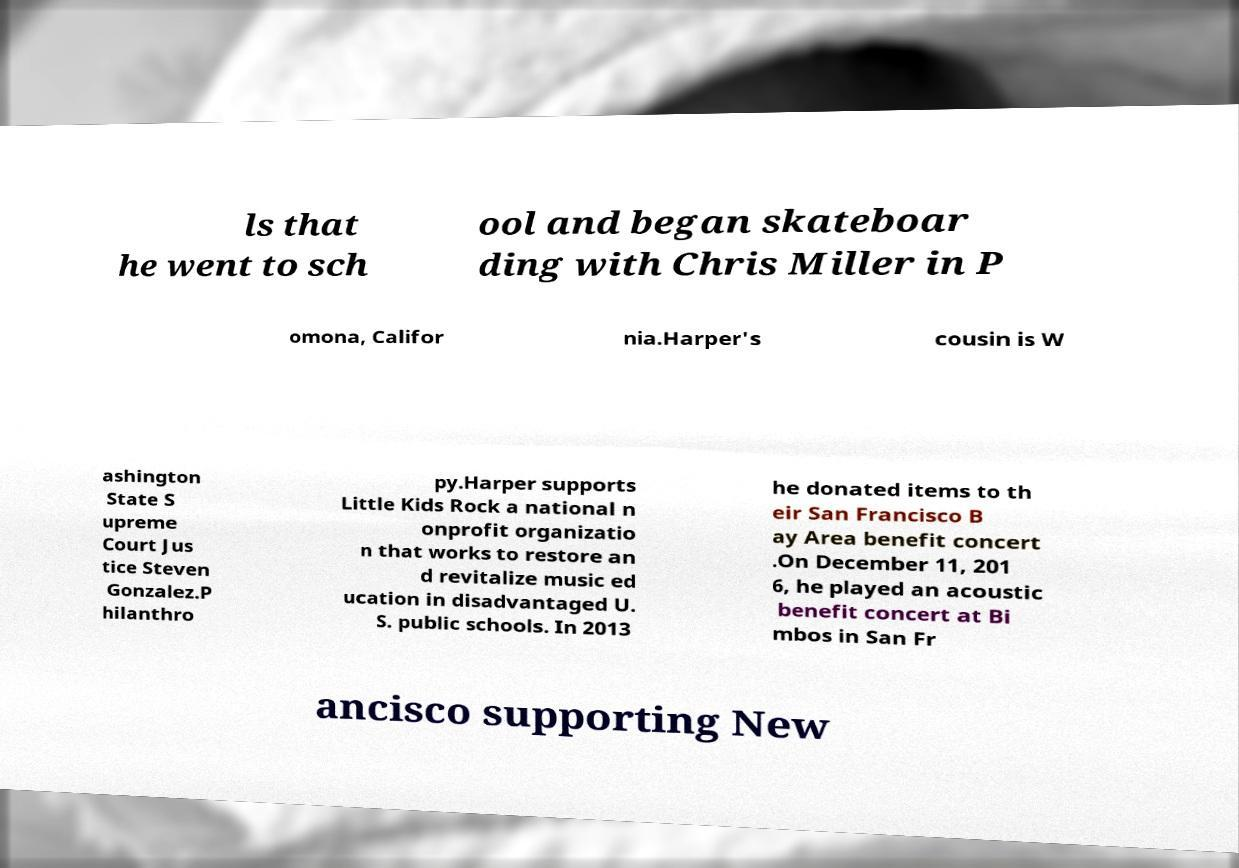Can you accurately transcribe the text from the provided image for me? ls that he went to sch ool and began skateboar ding with Chris Miller in P omona, Califor nia.Harper's cousin is W ashington State S upreme Court Jus tice Steven Gonzalez.P hilanthro py.Harper supports Little Kids Rock a national n onprofit organizatio n that works to restore an d revitalize music ed ucation in disadvantaged U. S. public schools. In 2013 he donated items to th eir San Francisco B ay Area benefit concert .On December 11, 201 6, he played an acoustic benefit concert at Bi mbos in San Fr ancisco supporting New 